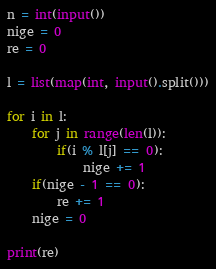<code> <loc_0><loc_0><loc_500><loc_500><_Python_>n = int(input())
nige = 0
re = 0

l = list(map(int, input().split()))

for i in l:
    for j in range(len(l)):
        if(i % l[j] == 0):
            nige += 1
    if(nige - 1 == 0):
        re += 1
    nige = 0
        
print(re)</code> 